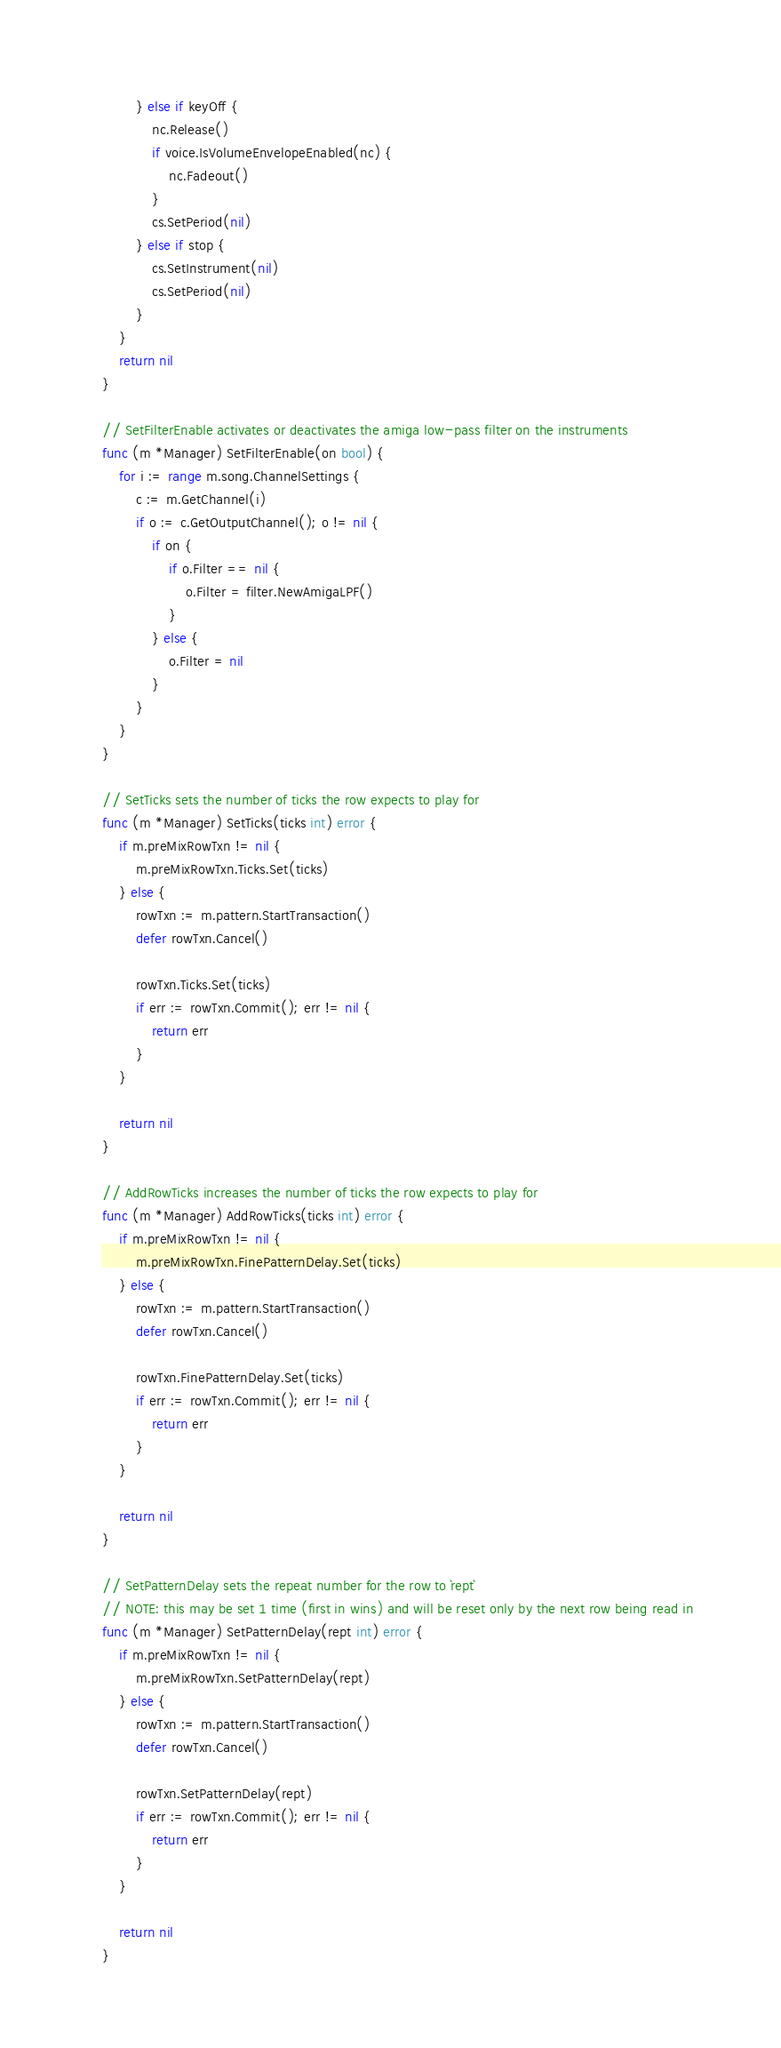Convert code to text. <code><loc_0><loc_0><loc_500><loc_500><_Go_>		} else if keyOff {
			nc.Release()
			if voice.IsVolumeEnvelopeEnabled(nc) {
				nc.Fadeout()
			}
			cs.SetPeriod(nil)
		} else if stop {
			cs.SetInstrument(nil)
			cs.SetPeriod(nil)
		}
	}
	return nil
}

// SetFilterEnable activates or deactivates the amiga low-pass filter on the instruments
func (m *Manager) SetFilterEnable(on bool) {
	for i := range m.song.ChannelSettings {
		c := m.GetChannel(i)
		if o := c.GetOutputChannel(); o != nil {
			if on {
				if o.Filter == nil {
					o.Filter = filter.NewAmigaLPF()
				}
			} else {
				o.Filter = nil
			}
		}
	}
}

// SetTicks sets the number of ticks the row expects to play for
func (m *Manager) SetTicks(ticks int) error {
	if m.preMixRowTxn != nil {
		m.preMixRowTxn.Ticks.Set(ticks)
	} else {
		rowTxn := m.pattern.StartTransaction()
		defer rowTxn.Cancel()

		rowTxn.Ticks.Set(ticks)
		if err := rowTxn.Commit(); err != nil {
			return err
		}
	}

	return nil
}

// AddRowTicks increases the number of ticks the row expects to play for
func (m *Manager) AddRowTicks(ticks int) error {
	if m.preMixRowTxn != nil {
		m.preMixRowTxn.FinePatternDelay.Set(ticks)
	} else {
		rowTxn := m.pattern.StartTransaction()
		defer rowTxn.Cancel()

		rowTxn.FinePatternDelay.Set(ticks)
		if err := rowTxn.Commit(); err != nil {
			return err
		}
	}

	return nil
}

// SetPatternDelay sets the repeat number for the row to `rept`
// NOTE: this may be set 1 time (first in wins) and will be reset only by the next row being read in
func (m *Manager) SetPatternDelay(rept int) error {
	if m.preMixRowTxn != nil {
		m.preMixRowTxn.SetPatternDelay(rept)
	} else {
		rowTxn := m.pattern.StartTransaction()
		defer rowTxn.Cancel()

		rowTxn.SetPatternDelay(rept)
		if err := rowTxn.Commit(); err != nil {
			return err
		}
	}

	return nil
}
</code> 